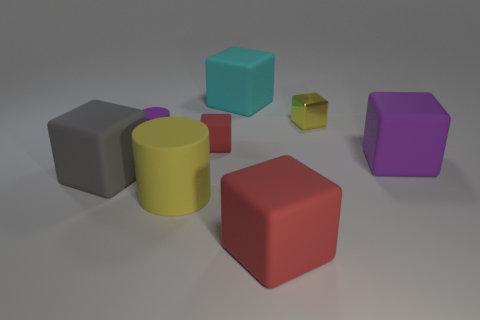Subtract all purple cubes. How many cubes are left? 5 Subtract 4 cubes. How many cubes are left? 2 Subtract all cyan blocks. How many blocks are left? 5 Add 1 small spheres. How many objects exist? 9 Subtract all green blocks. Subtract all blue spheres. How many blocks are left? 6 Subtract all cylinders. How many objects are left? 6 Add 1 spheres. How many spheres exist? 1 Subtract 0 cyan cylinders. How many objects are left? 8 Subtract all big green balls. Subtract all large yellow things. How many objects are left? 7 Add 4 tiny rubber cylinders. How many tiny rubber cylinders are left? 5 